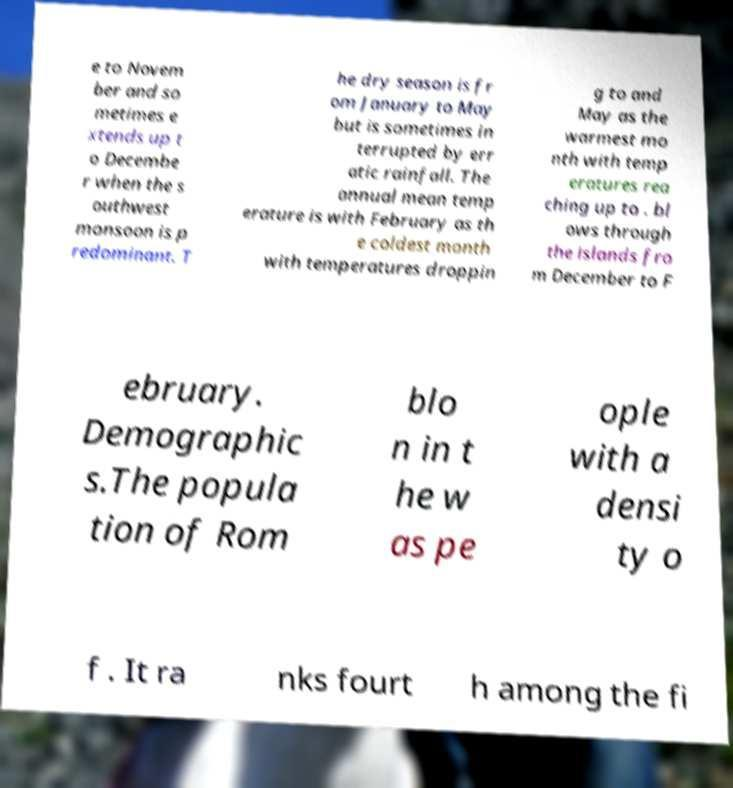Could you extract and type out the text from this image? e to Novem ber and so metimes e xtends up t o Decembe r when the s outhwest monsoon is p redominant. T he dry season is fr om January to May but is sometimes in terrupted by err atic rainfall. The annual mean temp erature is with February as th e coldest month with temperatures droppin g to and May as the warmest mo nth with temp eratures rea ching up to . bl ows through the islands fro m December to F ebruary. Demographic s.The popula tion of Rom blo n in t he w as pe ople with a densi ty o f . It ra nks fourt h among the fi 